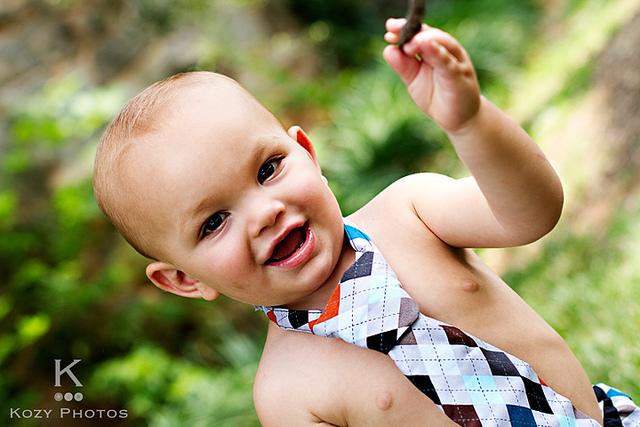Does this baby have any teeth?
Give a very brief answer. No. Where is the tie?
Concise answer only. On baby. Is this a baby's hand?
Answer briefly. Yes. What is the pattern on the tie?
Short answer required. Argyle. 